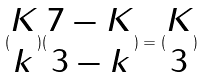Convert formula to latex. <formula><loc_0><loc_0><loc_500><loc_500>( \begin{matrix} K \\ k \end{matrix} ) ( \begin{matrix} 7 - K \\ 3 - k \end{matrix} ) = ( \begin{matrix} K \\ 3 \end{matrix} )</formula> 